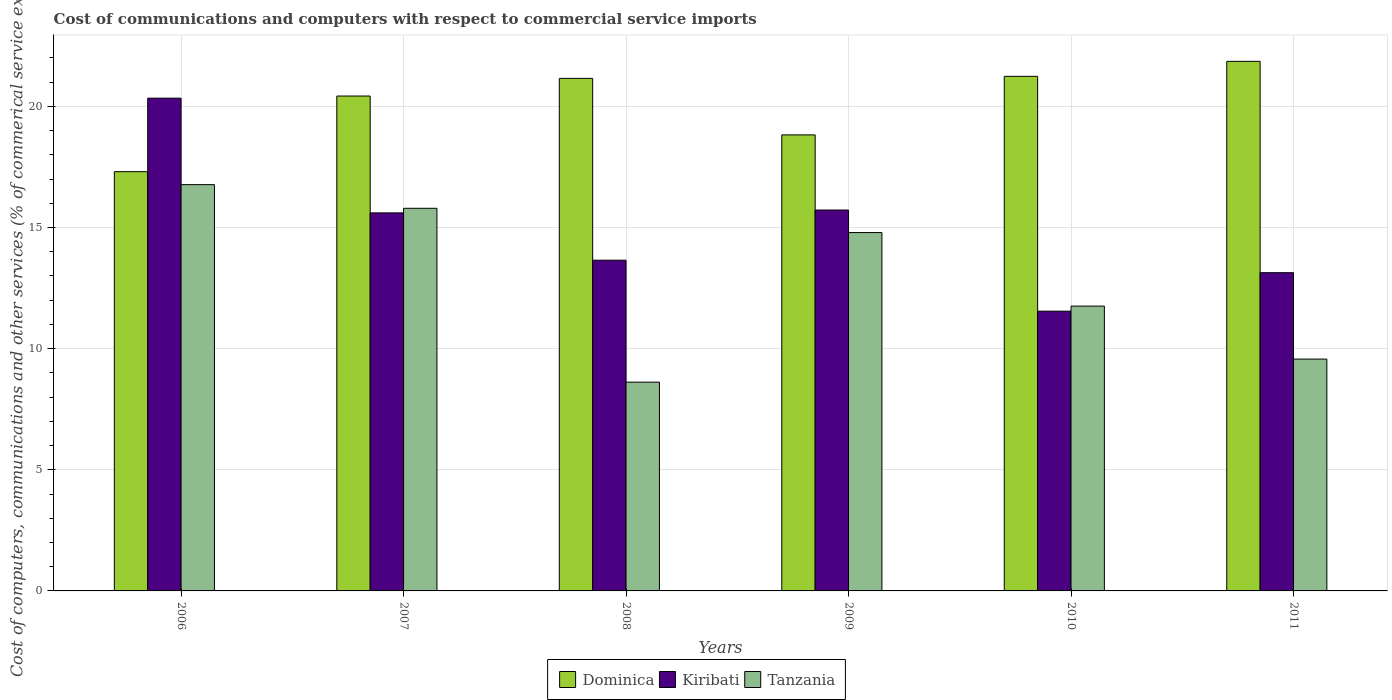How many groups of bars are there?
Offer a terse response. 6. Are the number of bars on each tick of the X-axis equal?
Provide a succinct answer. Yes. What is the cost of communications and computers in Tanzania in 2008?
Offer a very short reply. 8.62. Across all years, what is the maximum cost of communications and computers in Kiribati?
Provide a succinct answer. 20.34. Across all years, what is the minimum cost of communications and computers in Dominica?
Your answer should be compact. 17.3. What is the total cost of communications and computers in Dominica in the graph?
Your response must be concise. 120.8. What is the difference between the cost of communications and computers in Kiribati in 2006 and that in 2007?
Make the answer very short. 4.73. What is the difference between the cost of communications and computers in Kiribati in 2011 and the cost of communications and computers in Dominica in 2008?
Keep it short and to the point. -8.02. What is the average cost of communications and computers in Tanzania per year?
Provide a succinct answer. 12.88. In the year 2010, what is the difference between the cost of communications and computers in Kiribati and cost of communications and computers in Tanzania?
Provide a short and direct response. -0.21. What is the ratio of the cost of communications and computers in Kiribati in 2009 to that in 2010?
Make the answer very short. 1.36. Is the cost of communications and computers in Tanzania in 2008 less than that in 2011?
Make the answer very short. Yes. What is the difference between the highest and the second highest cost of communications and computers in Dominica?
Give a very brief answer. 0.62. What is the difference between the highest and the lowest cost of communications and computers in Kiribati?
Make the answer very short. 8.79. What does the 2nd bar from the left in 2006 represents?
Give a very brief answer. Kiribati. What does the 3rd bar from the right in 2008 represents?
Keep it short and to the point. Dominica. Is it the case that in every year, the sum of the cost of communications and computers in Tanzania and cost of communications and computers in Dominica is greater than the cost of communications and computers in Kiribati?
Your answer should be compact. Yes. How many bars are there?
Your answer should be very brief. 18. Are all the bars in the graph horizontal?
Make the answer very short. No. How many years are there in the graph?
Make the answer very short. 6. What is the difference between two consecutive major ticks on the Y-axis?
Offer a terse response. 5. How many legend labels are there?
Offer a very short reply. 3. How are the legend labels stacked?
Your answer should be compact. Horizontal. What is the title of the graph?
Make the answer very short. Cost of communications and computers with respect to commercial service imports. What is the label or title of the Y-axis?
Give a very brief answer. Cost of computers, communications and other services (% of commerical service exports). What is the Cost of computers, communications and other services (% of commerical service exports) in Dominica in 2006?
Ensure brevity in your answer.  17.3. What is the Cost of computers, communications and other services (% of commerical service exports) in Kiribati in 2006?
Provide a short and direct response. 20.34. What is the Cost of computers, communications and other services (% of commerical service exports) in Tanzania in 2006?
Make the answer very short. 16.77. What is the Cost of computers, communications and other services (% of commerical service exports) in Dominica in 2007?
Your answer should be compact. 20.43. What is the Cost of computers, communications and other services (% of commerical service exports) of Kiribati in 2007?
Provide a short and direct response. 15.6. What is the Cost of computers, communications and other services (% of commerical service exports) in Tanzania in 2007?
Your answer should be very brief. 15.79. What is the Cost of computers, communications and other services (% of commerical service exports) in Dominica in 2008?
Provide a succinct answer. 21.15. What is the Cost of computers, communications and other services (% of commerical service exports) of Kiribati in 2008?
Ensure brevity in your answer.  13.65. What is the Cost of computers, communications and other services (% of commerical service exports) of Tanzania in 2008?
Provide a short and direct response. 8.62. What is the Cost of computers, communications and other services (% of commerical service exports) of Dominica in 2009?
Ensure brevity in your answer.  18.82. What is the Cost of computers, communications and other services (% of commerical service exports) in Kiribati in 2009?
Offer a very short reply. 15.72. What is the Cost of computers, communications and other services (% of commerical service exports) of Tanzania in 2009?
Ensure brevity in your answer.  14.79. What is the Cost of computers, communications and other services (% of commerical service exports) in Dominica in 2010?
Your response must be concise. 21.24. What is the Cost of computers, communications and other services (% of commerical service exports) in Kiribati in 2010?
Give a very brief answer. 11.55. What is the Cost of computers, communications and other services (% of commerical service exports) of Tanzania in 2010?
Offer a very short reply. 11.76. What is the Cost of computers, communications and other services (% of commerical service exports) of Dominica in 2011?
Your answer should be very brief. 21.86. What is the Cost of computers, communications and other services (% of commerical service exports) in Kiribati in 2011?
Make the answer very short. 13.13. What is the Cost of computers, communications and other services (% of commerical service exports) of Tanzania in 2011?
Provide a short and direct response. 9.57. Across all years, what is the maximum Cost of computers, communications and other services (% of commerical service exports) in Dominica?
Ensure brevity in your answer.  21.86. Across all years, what is the maximum Cost of computers, communications and other services (% of commerical service exports) in Kiribati?
Give a very brief answer. 20.34. Across all years, what is the maximum Cost of computers, communications and other services (% of commerical service exports) in Tanzania?
Your response must be concise. 16.77. Across all years, what is the minimum Cost of computers, communications and other services (% of commerical service exports) of Dominica?
Offer a terse response. 17.3. Across all years, what is the minimum Cost of computers, communications and other services (% of commerical service exports) in Kiribati?
Your response must be concise. 11.55. Across all years, what is the minimum Cost of computers, communications and other services (% of commerical service exports) in Tanzania?
Your answer should be compact. 8.62. What is the total Cost of computers, communications and other services (% of commerical service exports) in Dominica in the graph?
Ensure brevity in your answer.  120.8. What is the total Cost of computers, communications and other services (% of commerical service exports) of Kiribati in the graph?
Your answer should be compact. 89.99. What is the total Cost of computers, communications and other services (% of commerical service exports) in Tanzania in the graph?
Your response must be concise. 77.29. What is the difference between the Cost of computers, communications and other services (% of commerical service exports) of Dominica in 2006 and that in 2007?
Give a very brief answer. -3.12. What is the difference between the Cost of computers, communications and other services (% of commerical service exports) of Kiribati in 2006 and that in 2007?
Provide a succinct answer. 4.73. What is the difference between the Cost of computers, communications and other services (% of commerical service exports) in Dominica in 2006 and that in 2008?
Keep it short and to the point. -3.85. What is the difference between the Cost of computers, communications and other services (% of commerical service exports) of Kiribati in 2006 and that in 2008?
Give a very brief answer. 6.69. What is the difference between the Cost of computers, communications and other services (% of commerical service exports) of Tanzania in 2006 and that in 2008?
Your answer should be very brief. 8.15. What is the difference between the Cost of computers, communications and other services (% of commerical service exports) in Dominica in 2006 and that in 2009?
Provide a succinct answer. -1.52. What is the difference between the Cost of computers, communications and other services (% of commerical service exports) of Kiribati in 2006 and that in 2009?
Keep it short and to the point. 4.62. What is the difference between the Cost of computers, communications and other services (% of commerical service exports) in Tanzania in 2006 and that in 2009?
Make the answer very short. 1.98. What is the difference between the Cost of computers, communications and other services (% of commerical service exports) of Dominica in 2006 and that in 2010?
Ensure brevity in your answer.  -3.93. What is the difference between the Cost of computers, communications and other services (% of commerical service exports) in Kiribati in 2006 and that in 2010?
Your answer should be compact. 8.79. What is the difference between the Cost of computers, communications and other services (% of commerical service exports) of Tanzania in 2006 and that in 2010?
Keep it short and to the point. 5.01. What is the difference between the Cost of computers, communications and other services (% of commerical service exports) of Dominica in 2006 and that in 2011?
Provide a succinct answer. -4.55. What is the difference between the Cost of computers, communications and other services (% of commerical service exports) in Kiribati in 2006 and that in 2011?
Offer a very short reply. 7.2. What is the difference between the Cost of computers, communications and other services (% of commerical service exports) of Tanzania in 2006 and that in 2011?
Offer a very short reply. 7.2. What is the difference between the Cost of computers, communications and other services (% of commerical service exports) of Dominica in 2007 and that in 2008?
Your response must be concise. -0.73. What is the difference between the Cost of computers, communications and other services (% of commerical service exports) of Kiribati in 2007 and that in 2008?
Your answer should be very brief. 1.95. What is the difference between the Cost of computers, communications and other services (% of commerical service exports) in Tanzania in 2007 and that in 2008?
Your answer should be compact. 7.18. What is the difference between the Cost of computers, communications and other services (% of commerical service exports) in Dominica in 2007 and that in 2009?
Provide a short and direct response. 1.6. What is the difference between the Cost of computers, communications and other services (% of commerical service exports) of Kiribati in 2007 and that in 2009?
Provide a short and direct response. -0.12. What is the difference between the Cost of computers, communications and other services (% of commerical service exports) of Dominica in 2007 and that in 2010?
Ensure brevity in your answer.  -0.81. What is the difference between the Cost of computers, communications and other services (% of commerical service exports) in Kiribati in 2007 and that in 2010?
Offer a very short reply. 4.06. What is the difference between the Cost of computers, communications and other services (% of commerical service exports) in Tanzania in 2007 and that in 2010?
Offer a very short reply. 4.04. What is the difference between the Cost of computers, communications and other services (% of commerical service exports) of Dominica in 2007 and that in 2011?
Provide a succinct answer. -1.43. What is the difference between the Cost of computers, communications and other services (% of commerical service exports) in Kiribati in 2007 and that in 2011?
Provide a succinct answer. 2.47. What is the difference between the Cost of computers, communications and other services (% of commerical service exports) of Tanzania in 2007 and that in 2011?
Give a very brief answer. 6.22. What is the difference between the Cost of computers, communications and other services (% of commerical service exports) in Dominica in 2008 and that in 2009?
Make the answer very short. 2.33. What is the difference between the Cost of computers, communications and other services (% of commerical service exports) of Kiribati in 2008 and that in 2009?
Ensure brevity in your answer.  -2.07. What is the difference between the Cost of computers, communications and other services (% of commerical service exports) of Tanzania in 2008 and that in 2009?
Your answer should be compact. -6.17. What is the difference between the Cost of computers, communications and other services (% of commerical service exports) in Dominica in 2008 and that in 2010?
Your response must be concise. -0.08. What is the difference between the Cost of computers, communications and other services (% of commerical service exports) of Kiribati in 2008 and that in 2010?
Provide a short and direct response. 2.1. What is the difference between the Cost of computers, communications and other services (% of commerical service exports) of Tanzania in 2008 and that in 2010?
Provide a succinct answer. -3.14. What is the difference between the Cost of computers, communications and other services (% of commerical service exports) of Dominica in 2008 and that in 2011?
Make the answer very short. -0.7. What is the difference between the Cost of computers, communications and other services (% of commerical service exports) in Kiribati in 2008 and that in 2011?
Your response must be concise. 0.52. What is the difference between the Cost of computers, communications and other services (% of commerical service exports) of Tanzania in 2008 and that in 2011?
Your answer should be very brief. -0.95. What is the difference between the Cost of computers, communications and other services (% of commerical service exports) in Dominica in 2009 and that in 2010?
Provide a succinct answer. -2.42. What is the difference between the Cost of computers, communications and other services (% of commerical service exports) of Kiribati in 2009 and that in 2010?
Keep it short and to the point. 4.18. What is the difference between the Cost of computers, communications and other services (% of commerical service exports) of Tanzania in 2009 and that in 2010?
Make the answer very short. 3.04. What is the difference between the Cost of computers, communications and other services (% of commerical service exports) in Dominica in 2009 and that in 2011?
Your response must be concise. -3.03. What is the difference between the Cost of computers, communications and other services (% of commerical service exports) of Kiribati in 2009 and that in 2011?
Provide a short and direct response. 2.59. What is the difference between the Cost of computers, communications and other services (% of commerical service exports) in Tanzania in 2009 and that in 2011?
Offer a terse response. 5.22. What is the difference between the Cost of computers, communications and other services (% of commerical service exports) of Dominica in 2010 and that in 2011?
Give a very brief answer. -0.62. What is the difference between the Cost of computers, communications and other services (% of commerical service exports) of Kiribati in 2010 and that in 2011?
Your response must be concise. -1.59. What is the difference between the Cost of computers, communications and other services (% of commerical service exports) in Tanzania in 2010 and that in 2011?
Keep it short and to the point. 2.19. What is the difference between the Cost of computers, communications and other services (% of commerical service exports) in Dominica in 2006 and the Cost of computers, communications and other services (% of commerical service exports) in Kiribati in 2007?
Your answer should be compact. 1.7. What is the difference between the Cost of computers, communications and other services (% of commerical service exports) in Dominica in 2006 and the Cost of computers, communications and other services (% of commerical service exports) in Tanzania in 2007?
Your answer should be compact. 1.51. What is the difference between the Cost of computers, communications and other services (% of commerical service exports) in Kiribati in 2006 and the Cost of computers, communications and other services (% of commerical service exports) in Tanzania in 2007?
Offer a very short reply. 4.54. What is the difference between the Cost of computers, communications and other services (% of commerical service exports) of Dominica in 2006 and the Cost of computers, communications and other services (% of commerical service exports) of Kiribati in 2008?
Ensure brevity in your answer.  3.65. What is the difference between the Cost of computers, communications and other services (% of commerical service exports) in Dominica in 2006 and the Cost of computers, communications and other services (% of commerical service exports) in Tanzania in 2008?
Give a very brief answer. 8.69. What is the difference between the Cost of computers, communications and other services (% of commerical service exports) of Kiribati in 2006 and the Cost of computers, communications and other services (% of commerical service exports) of Tanzania in 2008?
Keep it short and to the point. 11.72. What is the difference between the Cost of computers, communications and other services (% of commerical service exports) in Dominica in 2006 and the Cost of computers, communications and other services (% of commerical service exports) in Kiribati in 2009?
Offer a very short reply. 1.58. What is the difference between the Cost of computers, communications and other services (% of commerical service exports) in Dominica in 2006 and the Cost of computers, communications and other services (% of commerical service exports) in Tanzania in 2009?
Provide a succinct answer. 2.51. What is the difference between the Cost of computers, communications and other services (% of commerical service exports) in Kiribati in 2006 and the Cost of computers, communications and other services (% of commerical service exports) in Tanzania in 2009?
Offer a very short reply. 5.55. What is the difference between the Cost of computers, communications and other services (% of commerical service exports) in Dominica in 2006 and the Cost of computers, communications and other services (% of commerical service exports) in Kiribati in 2010?
Give a very brief answer. 5.76. What is the difference between the Cost of computers, communications and other services (% of commerical service exports) of Dominica in 2006 and the Cost of computers, communications and other services (% of commerical service exports) of Tanzania in 2010?
Your answer should be compact. 5.55. What is the difference between the Cost of computers, communications and other services (% of commerical service exports) in Kiribati in 2006 and the Cost of computers, communications and other services (% of commerical service exports) in Tanzania in 2010?
Provide a short and direct response. 8.58. What is the difference between the Cost of computers, communications and other services (% of commerical service exports) in Dominica in 2006 and the Cost of computers, communications and other services (% of commerical service exports) in Kiribati in 2011?
Make the answer very short. 4.17. What is the difference between the Cost of computers, communications and other services (% of commerical service exports) of Dominica in 2006 and the Cost of computers, communications and other services (% of commerical service exports) of Tanzania in 2011?
Make the answer very short. 7.74. What is the difference between the Cost of computers, communications and other services (% of commerical service exports) of Kiribati in 2006 and the Cost of computers, communications and other services (% of commerical service exports) of Tanzania in 2011?
Make the answer very short. 10.77. What is the difference between the Cost of computers, communications and other services (% of commerical service exports) in Dominica in 2007 and the Cost of computers, communications and other services (% of commerical service exports) in Kiribati in 2008?
Offer a terse response. 6.78. What is the difference between the Cost of computers, communications and other services (% of commerical service exports) of Dominica in 2007 and the Cost of computers, communications and other services (% of commerical service exports) of Tanzania in 2008?
Give a very brief answer. 11.81. What is the difference between the Cost of computers, communications and other services (% of commerical service exports) in Kiribati in 2007 and the Cost of computers, communications and other services (% of commerical service exports) in Tanzania in 2008?
Offer a very short reply. 6.99. What is the difference between the Cost of computers, communications and other services (% of commerical service exports) in Dominica in 2007 and the Cost of computers, communications and other services (% of commerical service exports) in Kiribati in 2009?
Give a very brief answer. 4.7. What is the difference between the Cost of computers, communications and other services (% of commerical service exports) of Dominica in 2007 and the Cost of computers, communications and other services (% of commerical service exports) of Tanzania in 2009?
Offer a terse response. 5.64. What is the difference between the Cost of computers, communications and other services (% of commerical service exports) of Kiribati in 2007 and the Cost of computers, communications and other services (% of commerical service exports) of Tanzania in 2009?
Offer a terse response. 0.81. What is the difference between the Cost of computers, communications and other services (% of commerical service exports) in Dominica in 2007 and the Cost of computers, communications and other services (% of commerical service exports) in Kiribati in 2010?
Your response must be concise. 8.88. What is the difference between the Cost of computers, communications and other services (% of commerical service exports) of Dominica in 2007 and the Cost of computers, communications and other services (% of commerical service exports) of Tanzania in 2010?
Offer a very short reply. 8.67. What is the difference between the Cost of computers, communications and other services (% of commerical service exports) of Kiribati in 2007 and the Cost of computers, communications and other services (% of commerical service exports) of Tanzania in 2010?
Give a very brief answer. 3.85. What is the difference between the Cost of computers, communications and other services (% of commerical service exports) in Dominica in 2007 and the Cost of computers, communications and other services (% of commerical service exports) in Kiribati in 2011?
Keep it short and to the point. 7.29. What is the difference between the Cost of computers, communications and other services (% of commerical service exports) of Dominica in 2007 and the Cost of computers, communications and other services (% of commerical service exports) of Tanzania in 2011?
Ensure brevity in your answer.  10.86. What is the difference between the Cost of computers, communications and other services (% of commerical service exports) of Kiribati in 2007 and the Cost of computers, communications and other services (% of commerical service exports) of Tanzania in 2011?
Give a very brief answer. 6.03. What is the difference between the Cost of computers, communications and other services (% of commerical service exports) of Dominica in 2008 and the Cost of computers, communications and other services (% of commerical service exports) of Kiribati in 2009?
Provide a succinct answer. 5.43. What is the difference between the Cost of computers, communications and other services (% of commerical service exports) of Dominica in 2008 and the Cost of computers, communications and other services (% of commerical service exports) of Tanzania in 2009?
Your response must be concise. 6.36. What is the difference between the Cost of computers, communications and other services (% of commerical service exports) of Kiribati in 2008 and the Cost of computers, communications and other services (% of commerical service exports) of Tanzania in 2009?
Keep it short and to the point. -1.14. What is the difference between the Cost of computers, communications and other services (% of commerical service exports) of Dominica in 2008 and the Cost of computers, communications and other services (% of commerical service exports) of Kiribati in 2010?
Your response must be concise. 9.61. What is the difference between the Cost of computers, communications and other services (% of commerical service exports) in Dominica in 2008 and the Cost of computers, communications and other services (% of commerical service exports) in Tanzania in 2010?
Offer a very short reply. 9.4. What is the difference between the Cost of computers, communications and other services (% of commerical service exports) of Kiribati in 2008 and the Cost of computers, communications and other services (% of commerical service exports) of Tanzania in 2010?
Provide a short and direct response. 1.89. What is the difference between the Cost of computers, communications and other services (% of commerical service exports) in Dominica in 2008 and the Cost of computers, communications and other services (% of commerical service exports) in Kiribati in 2011?
Keep it short and to the point. 8.02. What is the difference between the Cost of computers, communications and other services (% of commerical service exports) of Dominica in 2008 and the Cost of computers, communications and other services (% of commerical service exports) of Tanzania in 2011?
Your response must be concise. 11.59. What is the difference between the Cost of computers, communications and other services (% of commerical service exports) in Kiribati in 2008 and the Cost of computers, communications and other services (% of commerical service exports) in Tanzania in 2011?
Your answer should be compact. 4.08. What is the difference between the Cost of computers, communications and other services (% of commerical service exports) in Dominica in 2009 and the Cost of computers, communications and other services (% of commerical service exports) in Kiribati in 2010?
Offer a very short reply. 7.28. What is the difference between the Cost of computers, communications and other services (% of commerical service exports) of Dominica in 2009 and the Cost of computers, communications and other services (% of commerical service exports) of Tanzania in 2010?
Keep it short and to the point. 7.07. What is the difference between the Cost of computers, communications and other services (% of commerical service exports) of Kiribati in 2009 and the Cost of computers, communications and other services (% of commerical service exports) of Tanzania in 2010?
Provide a succinct answer. 3.97. What is the difference between the Cost of computers, communications and other services (% of commerical service exports) in Dominica in 2009 and the Cost of computers, communications and other services (% of commerical service exports) in Kiribati in 2011?
Provide a succinct answer. 5.69. What is the difference between the Cost of computers, communications and other services (% of commerical service exports) in Dominica in 2009 and the Cost of computers, communications and other services (% of commerical service exports) in Tanzania in 2011?
Offer a very short reply. 9.25. What is the difference between the Cost of computers, communications and other services (% of commerical service exports) of Kiribati in 2009 and the Cost of computers, communications and other services (% of commerical service exports) of Tanzania in 2011?
Offer a terse response. 6.15. What is the difference between the Cost of computers, communications and other services (% of commerical service exports) of Dominica in 2010 and the Cost of computers, communications and other services (% of commerical service exports) of Kiribati in 2011?
Offer a terse response. 8.1. What is the difference between the Cost of computers, communications and other services (% of commerical service exports) in Dominica in 2010 and the Cost of computers, communications and other services (% of commerical service exports) in Tanzania in 2011?
Ensure brevity in your answer.  11.67. What is the difference between the Cost of computers, communications and other services (% of commerical service exports) of Kiribati in 2010 and the Cost of computers, communications and other services (% of commerical service exports) of Tanzania in 2011?
Provide a succinct answer. 1.98. What is the average Cost of computers, communications and other services (% of commerical service exports) in Dominica per year?
Offer a very short reply. 20.13. What is the average Cost of computers, communications and other services (% of commerical service exports) in Kiribati per year?
Keep it short and to the point. 15. What is the average Cost of computers, communications and other services (% of commerical service exports) of Tanzania per year?
Make the answer very short. 12.88. In the year 2006, what is the difference between the Cost of computers, communications and other services (% of commerical service exports) of Dominica and Cost of computers, communications and other services (% of commerical service exports) of Kiribati?
Keep it short and to the point. -3.03. In the year 2006, what is the difference between the Cost of computers, communications and other services (% of commerical service exports) in Dominica and Cost of computers, communications and other services (% of commerical service exports) in Tanzania?
Provide a succinct answer. 0.54. In the year 2006, what is the difference between the Cost of computers, communications and other services (% of commerical service exports) of Kiribati and Cost of computers, communications and other services (% of commerical service exports) of Tanzania?
Make the answer very short. 3.57. In the year 2007, what is the difference between the Cost of computers, communications and other services (% of commerical service exports) of Dominica and Cost of computers, communications and other services (% of commerical service exports) of Kiribati?
Keep it short and to the point. 4.82. In the year 2007, what is the difference between the Cost of computers, communications and other services (% of commerical service exports) of Dominica and Cost of computers, communications and other services (% of commerical service exports) of Tanzania?
Your answer should be very brief. 4.63. In the year 2007, what is the difference between the Cost of computers, communications and other services (% of commerical service exports) in Kiribati and Cost of computers, communications and other services (% of commerical service exports) in Tanzania?
Offer a terse response. -0.19. In the year 2008, what is the difference between the Cost of computers, communications and other services (% of commerical service exports) of Dominica and Cost of computers, communications and other services (% of commerical service exports) of Kiribati?
Your response must be concise. 7.5. In the year 2008, what is the difference between the Cost of computers, communications and other services (% of commerical service exports) in Dominica and Cost of computers, communications and other services (% of commerical service exports) in Tanzania?
Your answer should be compact. 12.54. In the year 2008, what is the difference between the Cost of computers, communications and other services (% of commerical service exports) of Kiribati and Cost of computers, communications and other services (% of commerical service exports) of Tanzania?
Keep it short and to the point. 5.03. In the year 2009, what is the difference between the Cost of computers, communications and other services (% of commerical service exports) in Dominica and Cost of computers, communications and other services (% of commerical service exports) in Kiribati?
Provide a short and direct response. 3.1. In the year 2009, what is the difference between the Cost of computers, communications and other services (% of commerical service exports) in Dominica and Cost of computers, communications and other services (% of commerical service exports) in Tanzania?
Your response must be concise. 4.03. In the year 2009, what is the difference between the Cost of computers, communications and other services (% of commerical service exports) of Kiribati and Cost of computers, communications and other services (% of commerical service exports) of Tanzania?
Keep it short and to the point. 0.93. In the year 2010, what is the difference between the Cost of computers, communications and other services (% of commerical service exports) of Dominica and Cost of computers, communications and other services (% of commerical service exports) of Kiribati?
Provide a short and direct response. 9.69. In the year 2010, what is the difference between the Cost of computers, communications and other services (% of commerical service exports) of Dominica and Cost of computers, communications and other services (% of commerical service exports) of Tanzania?
Offer a terse response. 9.48. In the year 2010, what is the difference between the Cost of computers, communications and other services (% of commerical service exports) of Kiribati and Cost of computers, communications and other services (% of commerical service exports) of Tanzania?
Give a very brief answer. -0.21. In the year 2011, what is the difference between the Cost of computers, communications and other services (% of commerical service exports) in Dominica and Cost of computers, communications and other services (% of commerical service exports) in Kiribati?
Your response must be concise. 8.72. In the year 2011, what is the difference between the Cost of computers, communications and other services (% of commerical service exports) of Dominica and Cost of computers, communications and other services (% of commerical service exports) of Tanzania?
Your answer should be very brief. 12.29. In the year 2011, what is the difference between the Cost of computers, communications and other services (% of commerical service exports) in Kiribati and Cost of computers, communications and other services (% of commerical service exports) in Tanzania?
Your answer should be very brief. 3.57. What is the ratio of the Cost of computers, communications and other services (% of commerical service exports) of Dominica in 2006 to that in 2007?
Give a very brief answer. 0.85. What is the ratio of the Cost of computers, communications and other services (% of commerical service exports) in Kiribati in 2006 to that in 2007?
Give a very brief answer. 1.3. What is the ratio of the Cost of computers, communications and other services (% of commerical service exports) in Tanzania in 2006 to that in 2007?
Give a very brief answer. 1.06. What is the ratio of the Cost of computers, communications and other services (% of commerical service exports) in Dominica in 2006 to that in 2008?
Offer a very short reply. 0.82. What is the ratio of the Cost of computers, communications and other services (% of commerical service exports) of Kiribati in 2006 to that in 2008?
Offer a very short reply. 1.49. What is the ratio of the Cost of computers, communications and other services (% of commerical service exports) in Tanzania in 2006 to that in 2008?
Provide a succinct answer. 1.95. What is the ratio of the Cost of computers, communications and other services (% of commerical service exports) in Dominica in 2006 to that in 2009?
Your answer should be compact. 0.92. What is the ratio of the Cost of computers, communications and other services (% of commerical service exports) of Kiribati in 2006 to that in 2009?
Your answer should be compact. 1.29. What is the ratio of the Cost of computers, communications and other services (% of commerical service exports) in Tanzania in 2006 to that in 2009?
Offer a terse response. 1.13. What is the ratio of the Cost of computers, communications and other services (% of commerical service exports) in Dominica in 2006 to that in 2010?
Your answer should be compact. 0.81. What is the ratio of the Cost of computers, communications and other services (% of commerical service exports) in Kiribati in 2006 to that in 2010?
Your answer should be compact. 1.76. What is the ratio of the Cost of computers, communications and other services (% of commerical service exports) of Tanzania in 2006 to that in 2010?
Your response must be concise. 1.43. What is the ratio of the Cost of computers, communications and other services (% of commerical service exports) of Dominica in 2006 to that in 2011?
Make the answer very short. 0.79. What is the ratio of the Cost of computers, communications and other services (% of commerical service exports) of Kiribati in 2006 to that in 2011?
Offer a terse response. 1.55. What is the ratio of the Cost of computers, communications and other services (% of commerical service exports) of Tanzania in 2006 to that in 2011?
Give a very brief answer. 1.75. What is the ratio of the Cost of computers, communications and other services (% of commerical service exports) of Dominica in 2007 to that in 2008?
Ensure brevity in your answer.  0.97. What is the ratio of the Cost of computers, communications and other services (% of commerical service exports) in Kiribati in 2007 to that in 2008?
Keep it short and to the point. 1.14. What is the ratio of the Cost of computers, communications and other services (% of commerical service exports) in Tanzania in 2007 to that in 2008?
Offer a terse response. 1.83. What is the ratio of the Cost of computers, communications and other services (% of commerical service exports) of Dominica in 2007 to that in 2009?
Give a very brief answer. 1.09. What is the ratio of the Cost of computers, communications and other services (% of commerical service exports) of Tanzania in 2007 to that in 2009?
Give a very brief answer. 1.07. What is the ratio of the Cost of computers, communications and other services (% of commerical service exports) of Dominica in 2007 to that in 2010?
Provide a succinct answer. 0.96. What is the ratio of the Cost of computers, communications and other services (% of commerical service exports) of Kiribati in 2007 to that in 2010?
Provide a succinct answer. 1.35. What is the ratio of the Cost of computers, communications and other services (% of commerical service exports) of Tanzania in 2007 to that in 2010?
Give a very brief answer. 1.34. What is the ratio of the Cost of computers, communications and other services (% of commerical service exports) in Dominica in 2007 to that in 2011?
Offer a terse response. 0.93. What is the ratio of the Cost of computers, communications and other services (% of commerical service exports) in Kiribati in 2007 to that in 2011?
Ensure brevity in your answer.  1.19. What is the ratio of the Cost of computers, communications and other services (% of commerical service exports) of Tanzania in 2007 to that in 2011?
Keep it short and to the point. 1.65. What is the ratio of the Cost of computers, communications and other services (% of commerical service exports) of Dominica in 2008 to that in 2009?
Offer a terse response. 1.12. What is the ratio of the Cost of computers, communications and other services (% of commerical service exports) in Kiribati in 2008 to that in 2009?
Give a very brief answer. 0.87. What is the ratio of the Cost of computers, communications and other services (% of commerical service exports) in Tanzania in 2008 to that in 2009?
Keep it short and to the point. 0.58. What is the ratio of the Cost of computers, communications and other services (% of commerical service exports) in Dominica in 2008 to that in 2010?
Give a very brief answer. 1. What is the ratio of the Cost of computers, communications and other services (% of commerical service exports) of Kiribati in 2008 to that in 2010?
Ensure brevity in your answer.  1.18. What is the ratio of the Cost of computers, communications and other services (% of commerical service exports) of Tanzania in 2008 to that in 2010?
Your response must be concise. 0.73. What is the ratio of the Cost of computers, communications and other services (% of commerical service exports) in Dominica in 2008 to that in 2011?
Provide a succinct answer. 0.97. What is the ratio of the Cost of computers, communications and other services (% of commerical service exports) in Kiribati in 2008 to that in 2011?
Provide a succinct answer. 1.04. What is the ratio of the Cost of computers, communications and other services (% of commerical service exports) in Tanzania in 2008 to that in 2011?
Your response must be concise. 0.9. What is the ratio of the Cost of computers, communications and other services (% of commerical service exports) in Dominica in 2009 to that in 2010?
Your response must be concise. 0.89. What is the ratio of the Cost of computers, communications and other services (% of commerical service exports) of Kiribati in 2009 to that in 2010?
Your answer should be compact. 1.36. What is the ratio of the Cost of computers, communications and other services (% of commerical service exports) in Tanzania in 2009 to that in 2010?
Make the answer very short. 1.26. What is the ratio of the Cost of computers, communications and other services (% of commerical service exports) of Dominica in 2009 to that in 2011?
Your answer should be compact. 0.86. What is the ratio of the Cost of computers, communications and other services (% of commerical service exports) of Kiribati in 2009 to that in 2011?
Your answer should be compact. 1.2. What is the ratio of the Cost of computers, communications and other services (% of commerical service exports) in Tanzania in 2009 to that in 2011?
Offer a terse response. 1.55. What is the ratio of the Cost of computers, communications and other services (% of commerical service exports) of Dominica in 2010 to that in 2011?
Give a very brief answer. 0.97. What is the ratio of the Cost of computers, communications and other services (% of commerical service exports) of Kiribati in 2010 to that in 2011?
Ensure brevity in your answer.  0.88. What is the ratio of the Cost of computers, communications and other services (% of commerical service exports) of Tanzania in 2010 to that in 2011?
Offer a terse response. 1.23. What is the difference between the highest and the second highest Cost of computers, communications and other services (% of commerical service exports) in Dominica?
Offer a very short reply. 0.62. What is the difference between the highest and the second highest Cost of computers, communications and other services (% of commerical service exports) in Kiribati?
Your answer should be compact. 4.62. What is the difference between the highest and the lowest Cost of computers, communications and other services (% of commerical service exports) of Dominica?
Ensure brevity in your answer.  4.55. What is the difference between the highest and the lowest Cost of computers, communications and other services (% of commerical service exports) in Kiribati?
Give a very brief answer. 8.79. What is the difference between the highest and the lowest Cost of computers, communications and other services (% of commerical service exports) in Tanzania?
Give a very brief answer. 8.15. 